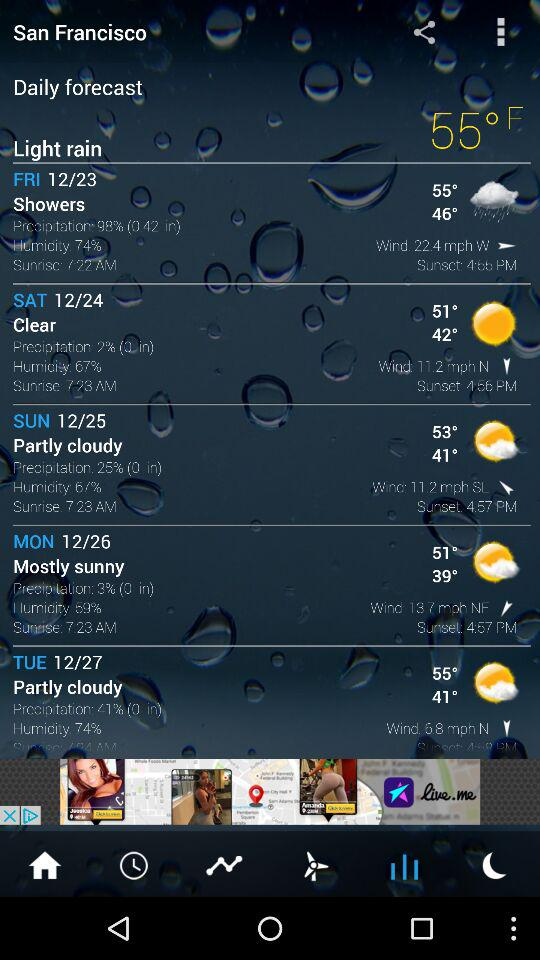What is the humidity percentage on Saturday? The humidity percentage on Saturday is 67. 